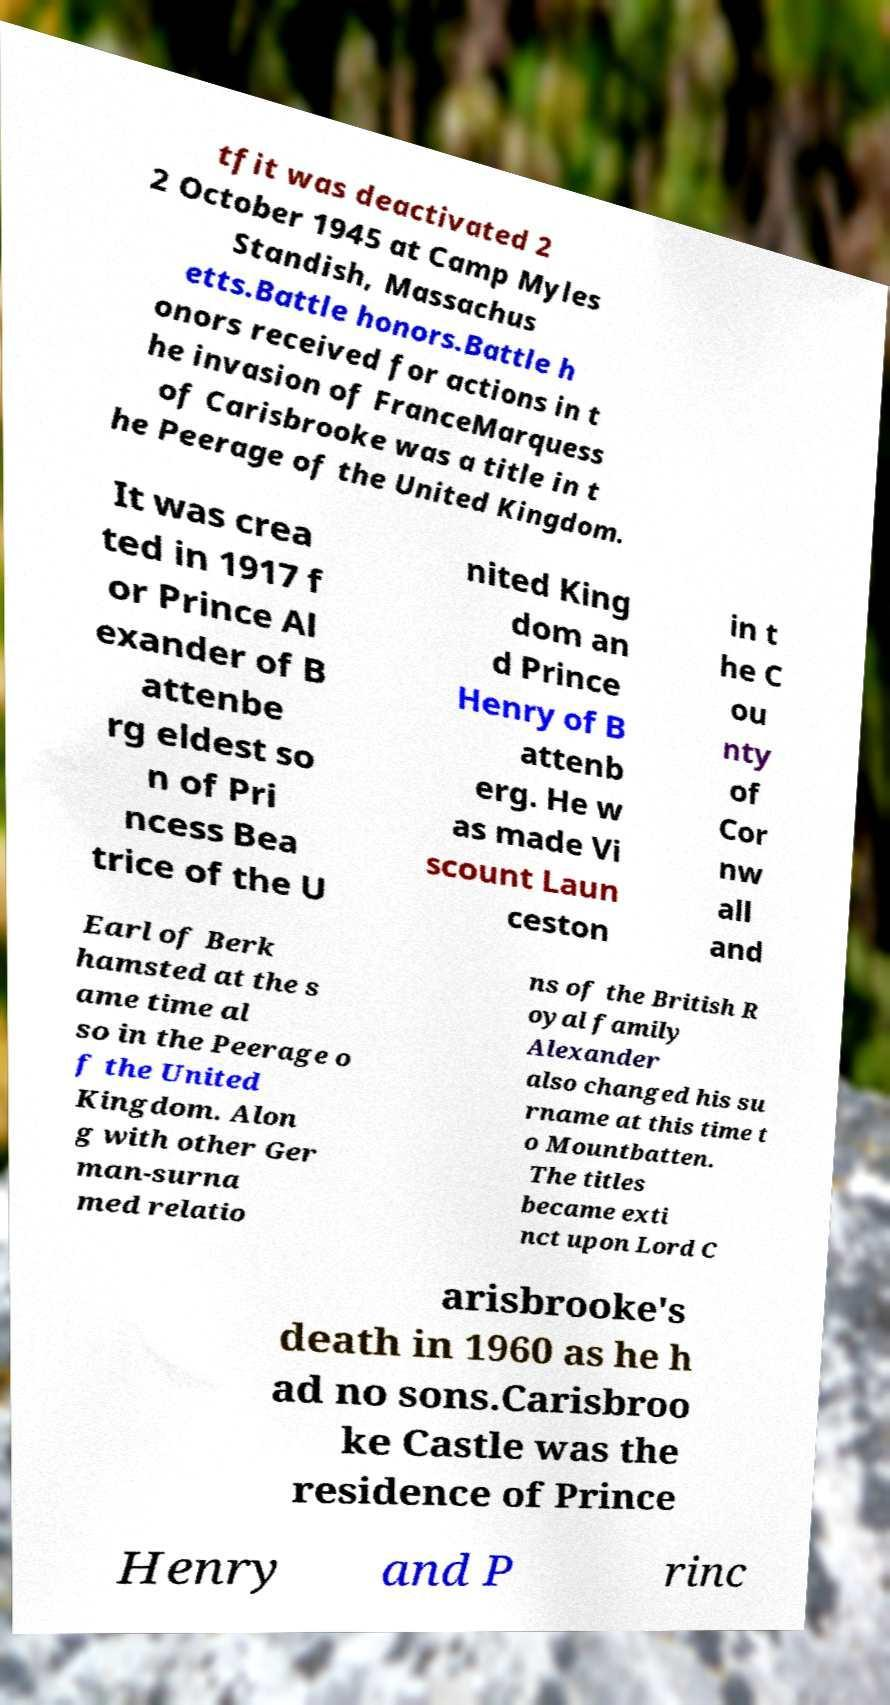What messages or text are displayed in this image? I need them in a readable, typed format. tfit was deactivated 2 2 October 1945 at Camp Myles Standish, Massachus etts.Battle honors.Battle h onors received for actions in t he invasion of FranceMarquess of Carisbrooke was a title in t he Peerage of the United Kingdom. It was crea ted in 1917 f or Prince Al exander of B attenbe rg eldest so n of Pri ncess Bea trice of the U nited King dom an d Prince Henry of B attenb erg. He w as made Vi scount Laun ceston in t he C ou nty of Cor nw all and Earl of Berk hamsted at the s ame time al so in the Peerage o f the United Kingdom. Alon g with other Ger man-surna med relatio ns of the British R oyal family Alexander also changed his su rname at this time t o Mountbatten. The titles became exti nct upon Lord C arisbrooke's death in 1960 as he h ad no sons.Carisbroo ke Castle was the residence of Prince Henry and P rinc 